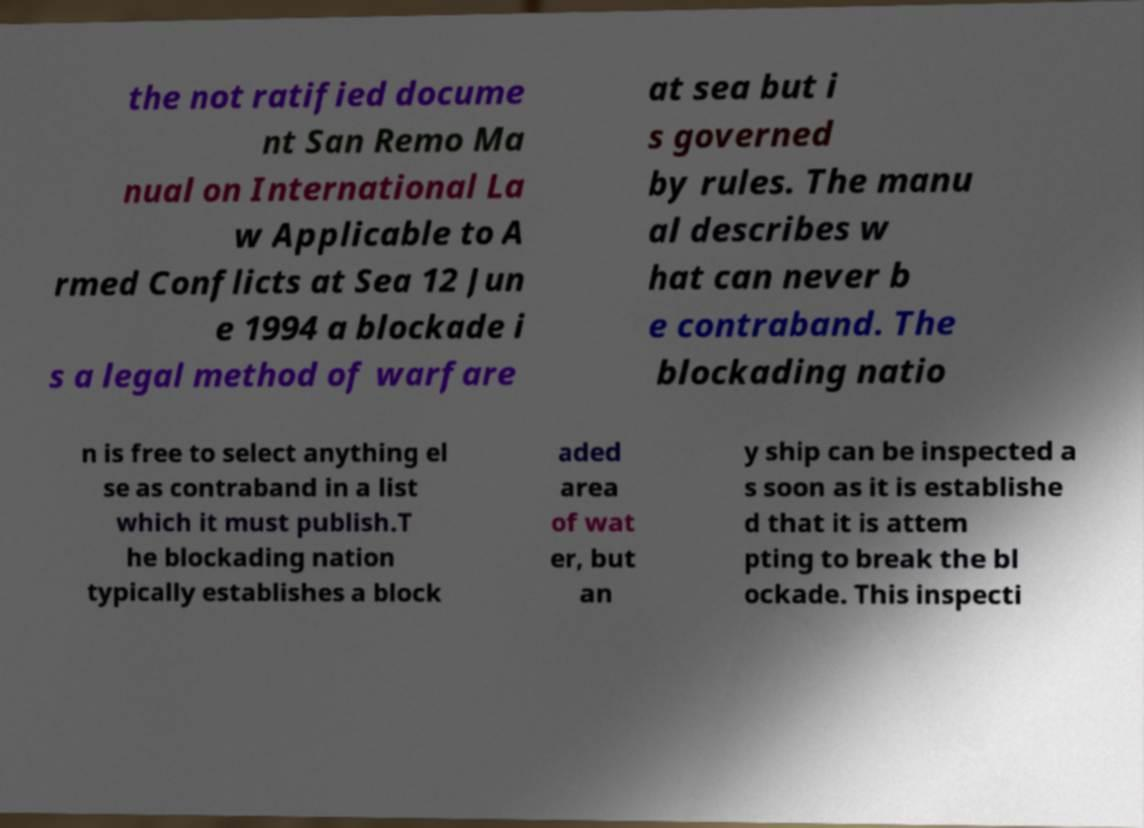There's text embedded in this image that I need extracted. Can you transcribe it verbatim? the not ratified docume nt San Remo Ma nual on International La w Applicable to A rmed Conflicts at Sea 12 Jun e 1994 a blockade i s a legal method of warfare at sea but i s governed by rules. The manu al describes w hat can never b e contraband. The blockading natio n is free to select anything el se as contraband in a list which it must publish.T he blockading nation typically establishes a block aded area of wat er, but an y ship can be inspected a s soon as it is establishe d that it is attem pting to break the bl ockade. This inspecti 